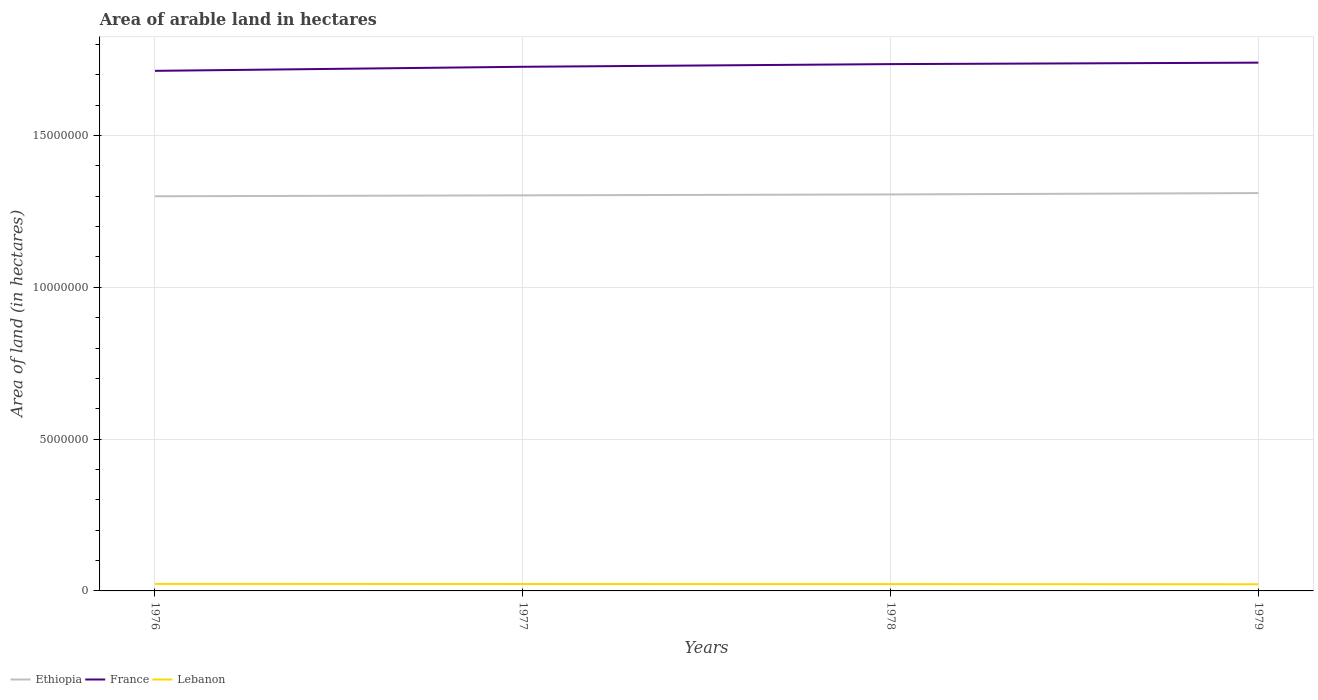Across all years, what is the maximum total arable land in France?
Offer a very short reply. 1.71e+07. In which year was the total arable land in Ethiopia maximum?
Provide a short and direct response. 1976. What is the total total arable land in France in the graph?
Keep it short and to the point. -2.70e+05. What is the difference between the highest and the second highest total arable land in Ethiopia?
Your answer should be very brief. 1.05e+05. What is the difference between the highest and the lowest total arable land in France?
Keep it short and to the point. 2. How many lines are there?
Your response must be concise. 3. How many years are there in the graph?
Keep it short and to the point. 4. Where does the legend appear in the graph?
Your response must be concise. Bottom left. How are the legend labels stacked?
Your response must be concise. Horizontal. What is the title of the graph?
Keep it short and to the point. Area of arable land in hectares. Does "Central African Republic" appear as one of the legend labels in the graph?
Provide a short and direct response. No. What is the label or title of the X-axis?
Offer a terse response. Years. What is the label or title of the Y-axis?
Give a very brief answer. Area of land (in hectares). What is the Area of land (in hectares) of Ethiopia in 1976?
Your answer should be compact. 1.30e+07. What is the Area of land (in hectares) of France in 1976?
Your answer should be compact. 1.71e+07. What is the Area of land (in hectares) in Lebanon in 1976?
Ensure brevity in your answer.  2.31e+05. What is the Area of land (in hectares) in Ethiopia in 1977?
Provide a short and direct response. 1.30e+07. What is the Area of land (in hectares) in France in 1977?
Your answer should be very brief. 1.73e+07. What is the Area of land (in hectares) of Lebanon in 1977?
Your answer should be very brief. 2.28e+05. What is the Area of land (in hectares) in Ethiopia in 1978?
Give a very brief answer. 1.31e+07. What is the Area of land (in hectares) in France in 1978?
Your answer should be very brief. 1.74e+07. What is the Area of land (in hectares) in Lebanon in 1978?
Provide a succinct answer. 2.24e+05. What is the Area of land (in hectares) of Ethiopia in 1979?
Make the answer very short. 1.31e+07. What is the Area of land (in hectares) in France in 1979?
Your answer should be compact. 1.74e+07. Across all years, what is the maximum Area of land (in hectares) of Ethiopia?
Make the answer very short. 1.31e+07. Across all years, what is the maximum Area of land (in hectares) of France?
Your response must be concise. 1.74e+07. Across all years, what is the maximum Area of land (in hectares) of Lebanon?
Your answer should be very brief. 2.31e+05. Across all years, what is the minimum Area of land (in hectares) of Ethiopia?
Provide a succinct answer. 1.30e+07. Across all years, what is the minimum Area of land (in hectares) of France?
Provide a short and direct response. 1.71e+07. Across all years, what is the minimum Area of land (in hectares) of Lebanon?
Give a very brief answer. 2.20e+05. What is the total Area of land (in hectares) in Ethiopia in the graph?
Provide a short and direct response. 5.22e+07. What is the total Area of land (in hectares) in France in the graph?
Offer a very short reply. 6.92e+07. What is the total Area of land (in hectares) in Lebanon in the graph?
Offer a very short reply. 9.03e+05. What is the difference between the Area of land (in hectares) of France in 1976 and that in 1977?
Provide a short and direct response. -1.34e+05. What is the difference between the Area of land (in hectares) of Lebanon in 1976 and that in 1977?
Keep it short and to the point. 3000. What is the difference between the Area of land (in hectares) of Ethiopia in 1976 and that in 1978?
Your answer should be very brief. -6.00e+04. What is the difference between the Area of land (in hectares) of France in 1976 and that in 1978?
Give a very brief answer. -2.22e+05. What is the difference between the Area of land (in hectares) in Lebanon in 1976 and that in 1978?
Offer a terse response. 7000. What is the difference between the Area of land (in hectares) in Ethiopia in 1976 and that in 1979?
Provide a succinct answer. -1.05e+05. What is the difference between the Area of land (in hectares) in France in 1976 and that in 1979?
Provide a short and direct response. -2.70e+05. What is the difference between the Area of land (in hectares) in Lebanon in 1976 and that in 1979?
Provide a succinct answer. 1.10e+04. What is the difference between the Area of land (in hectares) of Ethiopia in 1977 and that in 1978?
Make the answer very short. -3.00e+04. What is the difference between the Area of land (in hectares) of France in 1977 and that in 1978?
Give a very brief answer. -8.80e+04. What is the difference between the Area of land (in hectares) in Lebanon in 1977 and that in 1978?
Ensure brevity in your answer.  4000. What is the difference between the Area of land (in hectares) in Ethiopia in 1977 and that in 1979?
Your answer should be compact. -7.50e+04. What is the difference between the Area of land (in hectares) in France in 1977 and that in 1979?
Offer a terse response. -1.36e+05. What is the difference between the Area of land (in hectares) in Lebanon in 1977 and that in 1979?
Your response must be concise. 8000. What is the difference between the Area of land (in hectares) of Ethiopia in 1978 and that in 1979?
Give a very brief answer. -4.50e+04. What is the difference between the Area of land (in hectares) of France in 1978 and that in 1979?
Ensure brevity in your answer.  -4.80e+04. What is the difference between the Area of land (in hectares) of Lebanon in 1978 and that in 1979?
Your answer should be very brief. 4000. What is the difference between the Area of land (in hectares) in Ethiopia in 1976 and the Area of land (in hectares) in France in 1977?
Offer a very short reply. -4.26e+06. What is the difference between the Area of land (in hectares) in Ethiopia in 1976 and the Area of land (in hectares) in Lebanon in 1977?
Offer a terse response. 1.28e+07. What is the difference between the Area of land (in hectares) of France in 1976 and the Area of land (in hectares) of Lebanon in 1977?
Ensure brevity in your answer.  1.69e+07. What is the difference between the Area of land (in hectares) in Ethiopia in 1976 and the Area of land (in hectares) in France in 1978?
Provide a short and direct response. -4.35e+06. What is the difference between the Area of land (in hectares) of Ethiopia in 1976 and the Area of land (in hectares) of Lebanon in 1978?
Your answer should be very brief. 1.28e+07. What is the difference between the Area of land (in hectares) of France in 1976 and the Area of land (in hectares) of Lebanon in 1978?
Provide a succinct answer. 1.69e+07. What is the difference between the Area of land (in hectares) in Ethiopia in 1976 and the Area of land (in hectares) in France in 1979?
Your answer should be very brief. -4.40e+06. What is the difference between the Area of land (in hectares) of Ethiopia in 1976 and the Area of land (in hectares) of Lebanon in 1979?
Provide a succinct answer. 1.28e+07. What is the difference between the Area of land (in hectares) of France in 1976 and the Area of land (in hectares) of Lebanon in 1979?
Offer a terse response. 1.69e+07. What is the difference between the Area of land (in hectares) of Ethiopia in 1977 and the Area of land (in hectares) of France in 1978?
Offer a very short reply. -4.32e+06. What is the difference between the Area of land (in hectares) in Ethiopia in 1977 and the Area of land (in hectares) in Lebanon in 1978?
Ensure brevity in your answer.  1.28e+07. What is the difference between the Area of land (in hectares) of France in 1977 and the Area of land (in hectares) of Lebanon in 1978?
Give a very brief answer. 1.70e+07. What is the difference between the Area of land (in hectares) of Ethiopia in 1977 and the Area of land (in hectares) of France in 1979?
Give a very brief answer. -4.37e+06. What is the difference between the Area of land (in hectares) in Ethiopia in 1977 and the Area of land (in hectares) in Lebanon in 1979?
Offer a very short reply. 1.28e+07. What is the difference between the Area of land (in hectares) of France in 1977 and the Area of land (in hectares) of Lebanon in 1979?
Offer a terse response. 1.70e+07. What is the difference between the Area of land (in hectares) in Ethiopia in 1978 and the Area of land (in hectares) in France in 1979?
Provide a short and direct response. -4.34e+06. What is the difference between the Area of land (in hectares) in Ethiopia in 1978 and the Area of land (in hectares) in Lebanon in 1979?
Offer a terse response. 1.28e+07. What is the difference between the Area of land (in hectares) of France in 1978 and the Area of land (in hectares) of Lebanon in 1979?
Your answer should be compact. 1.71e+07. What is the average Area of land (in hectares) of Ethiopia per year?
Offer a very short reply. 1.30e+07. What is the average Area of land (in hectares) of France per year?
Provide a succinct answer. 1.73e+07. What is the average Area of land (in hectares) in Lebanon per year?
Your response must be concise. 2.26e+05. In the year 1976, what is the difference between the Area of land (in hectares) of Ethiopia and Area of land (in hectares) of France?
Offer a terse response. -4.13e+06. In the year 1976, what is the difference between the Area of land (in hectares) in Ethiopia and Area of land (in hectares) in Lebanon?
Ensure brevity in your answer.  1.28e+07. In the year 1976, what is the difference between the Area of land (in hectares) of France and Area of land (in hectares) of Lebanon?
Provide a succinct answer. 1.69e+07. In the year 1977, what is the difference between the Area of land (in hectares) in Ethiopia and Area of land (in hectares) in France?
Provide a short and direct response. -4.24e+06. In the year 1977, what is the difference between the Area of land (in hectares) of Ethiopia and Area of land (in hectares) of Lebanon?
Keep it short and to the point. 1.28e+07. In the year 1977, what is the difference between the Area of land (in hectares) in France and Area of land (in hectares) in Lebanon?
Make the answer very short. 1.70e+07. In the year 1978, what is the difference between the Area of land (in hectares) in Ethiopia and Area of land (in hectares) in France?
Make the answer very short. -4.29e+06. In the year 1978, what is the difference between the Area of land (in hectares) in Ethiopia and Area of land (in hectares) in Lebanon?
Ensure brevity in your answer.  1.28e+07. In the year 1978, what is the difference between the Area of land (in hectares) in France and Area of land (in hectares) in Lebanon?
Keep it short and to the point. 1.71e+07. In the year 1979, what is the difference between the Area of land (in hectares) of Ethiopia and Area of land (in hectares) of France?
Your answer should be compact. -4.30e+06. In the year 1979, what is the difference between the Area of land (in hectares) of Ethiopia and Area of land (in hectares) of Lebanon?
Give a very brief answer. 1.29e+07. In the year 1979, what is the difference between the Area of land (in hectares) in France and Area of land (in hectares) in Lebanon?
Your answer should be compact. 1.72e+07. What is the ratio of the Area of land (in hectares) in Lebanon in 1976 to that in 1977?
Offer a terse response. 1.01. What is the ratio of the Area of land (in hectares) of Ethiopia in 1976 to that in 1978?
Your answer should be very brief. 1. What is the ratio of the Area of land (in hectares) of France in 1976 to that in 1978?
Your response must be concise. 0.99. What is the ratio of the Area of land (in hectares) of Lebanon in 1976 to that in 1978?
Provide a succinct answer. 1.03. What is the ratio of the Area of land (in hectares) of France in 1976 to that in 1979?
Your answer should be compact. 0.98. What is the ratio of the Area of land (in hectares) in Lebanon in 1976 to that in 1979?
Give a very brief answer. 1.05. What is the ratio of the Area of land (in hectares) of Ethiopia in 1977 to that in 1978?
Your response must be concise. 1. What is the ratio of the Area of land (in hectares) in France in 1977 to that in 1978?
Offer a very short reply. 0.99. What is the ratio of the Area of land (in hectares) in Lebanon in 1977 to that in 1978?
Offer a terse response. 1.02. What is the ratio of the Area of land (in hectares) in Ethiopia in 1977 to that in 1979?
Offer a very short reply. 0.99. What is the ratio of the Area of land (in hectares) of France in 1977 to that in 1979?
Keep it short and to the point. 0.99. What is the ratio of the Area of land (in hectares) in Lebanon in 1977 to that in 1979?
Offer a very short reply. 1.04. What is the ratio of the Area of land (in hectares) in France in 1978 to that in 1979?
Keep it short and to the point. 1. What is the ratio of the Area of land (in hectares) in Lebanon in 1978 to that in 1979?
Offer a very short reply. 1.02. What is the difference between the highest and the second highest Area of land (in hectares) in Ethiopia?
Ensure brevity in your answer.  4.50e+04. What is the difference between the highest and the second highest Area of land (in hectares) of France?
Your answer should be very brief. 4.80e+04. What is the difference between the highest and the second highest Area of land (in hectares) in Lebanon?
Keep it short and to the point. 3000. What is the difference between the highest and the lowest Area of land (in hectares) in Ethiopia?
Your answer should be compact. 1.05e+05. What is the difference between the highest and the lowest Area of land (in hectares) in Lebanon?
Keep it short and to the point. 1.10e+04. 